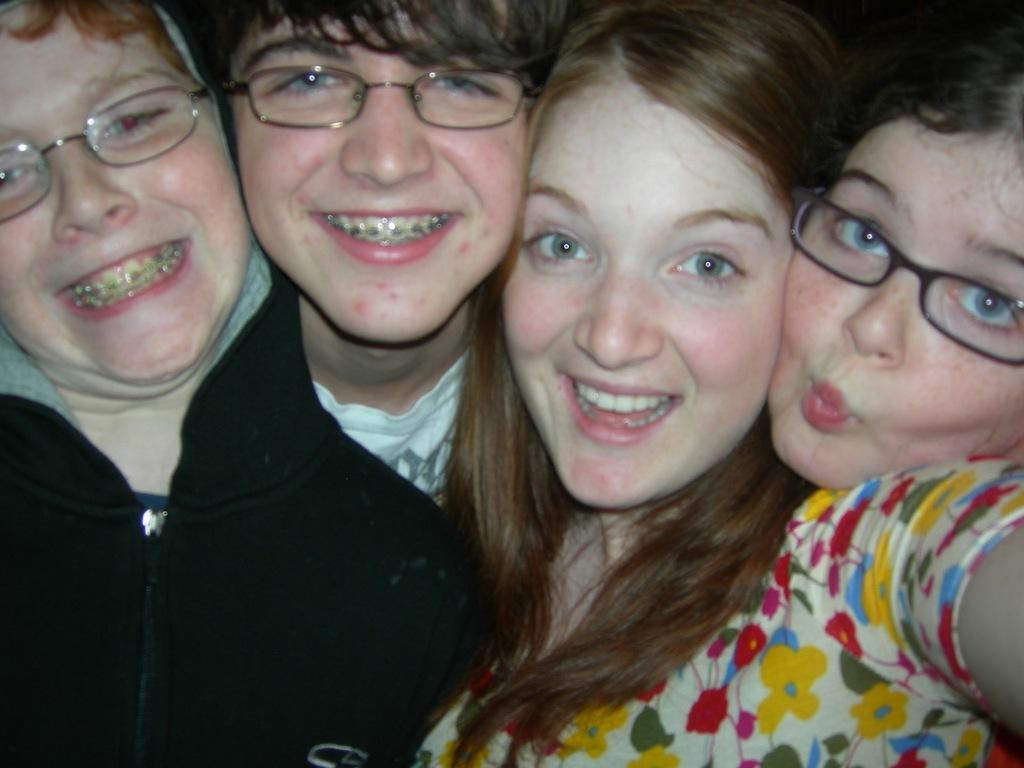How many people are in the image? There are four persons in the image. What can be observed about the attire of the persons? The persons are wearing different color dresses. What is the facial expression of the persons in the image? The persons are smiling. How many of the persons are wearing spectacles? Three of the persons are wearing spectacles. What type of vest can be seen on the chicken in the image? There is: There is no chicken present in the image, and therefore no vest can be observed. 